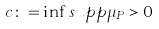<formula> <loc_0><loc_0><loc_500><loc_500>c \colon = \inf s u p p \mu _ { P } > 0</formula> 